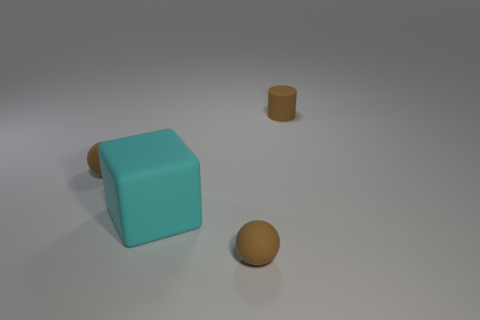Are there any other things that have the same shape as the big cyan thing?
Provide a succinct answer. No. Is there anything else that has the same size as the cyan rubber object?
Provide a succinct answer. No. The cyan rubber thing has what shape?
Your answer should be compact. Cube. What number of objects are either balls in front of the big block or big green matte spheres?
Offer a very short reply. 1. How many other things are the same color as the tiny matte cylinder?
Provide a short and direct response. 2. There is a cylinder; is it the same color as the rubber sphere that is on the right side of the large block?
Offer a terse response. Yes. Is the cylinder made of the same material as the small brown object that is in front of the cyan matte block?
Provide a short and direct response. Yes. What color is the cylinder?
Make the answer very short. Brown. There is a object right of the small brown sphere that is right of the sphere left of the big cyan object; what color is it?
Keep it short and to the point. Brown. There is a matte object that is both on the right side of the block and left of the tiny cylinder; what is its color?
Make the answer very short. Brown. 